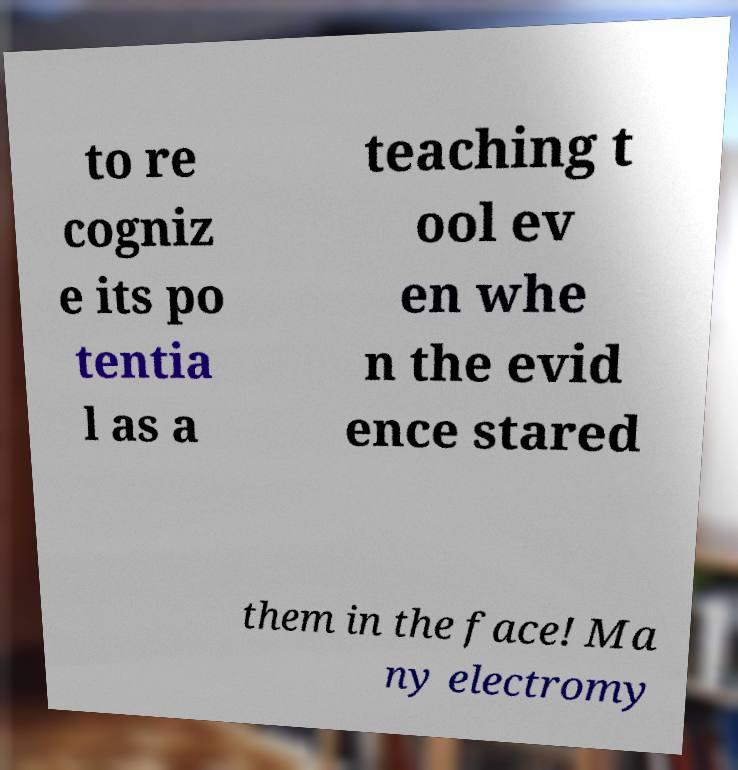Please identify and transcribe the text found in this image. to re cogniz e its po tentia l as a teaching t ool ev en whe n the evid ence stared them in the face! Ma ny electromy 